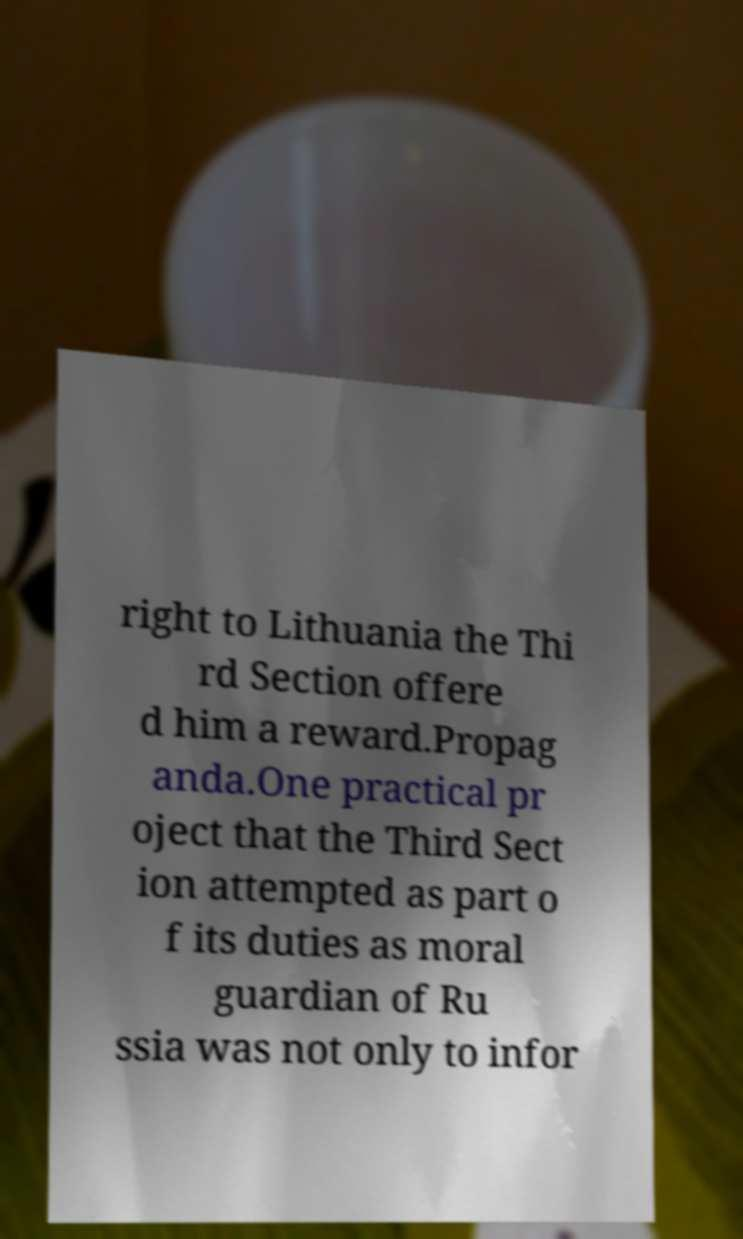For documentation purposes, I need the text within this image transcribed. Could you provide that? right to Lithuania the Thi rd Section offere d him a reward.Propag anda.One practical pr oject that the Third Sect ion attempted as part o f its duties as moral guardian of Ru ssia was not only to infor 